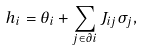Convert formula to latex. <formula><loc_0><loc_0><loc_500><loc_500>h _ { i } = \theta _ { i } + \sum _ { j \in \partial i } J _ { i j } \sigma _ { j } ,</formula> 